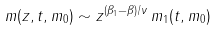Convert formula to latex. <formula><loc_0><loc_0><loc_500><loc_500>m ( z , t , m _ { 0 } ) \sim z ^ { ( \beta _ { 1 } - \beta ) / \nu } \, m _ { 1 } ( t , m _ { 0 } )</formula> 